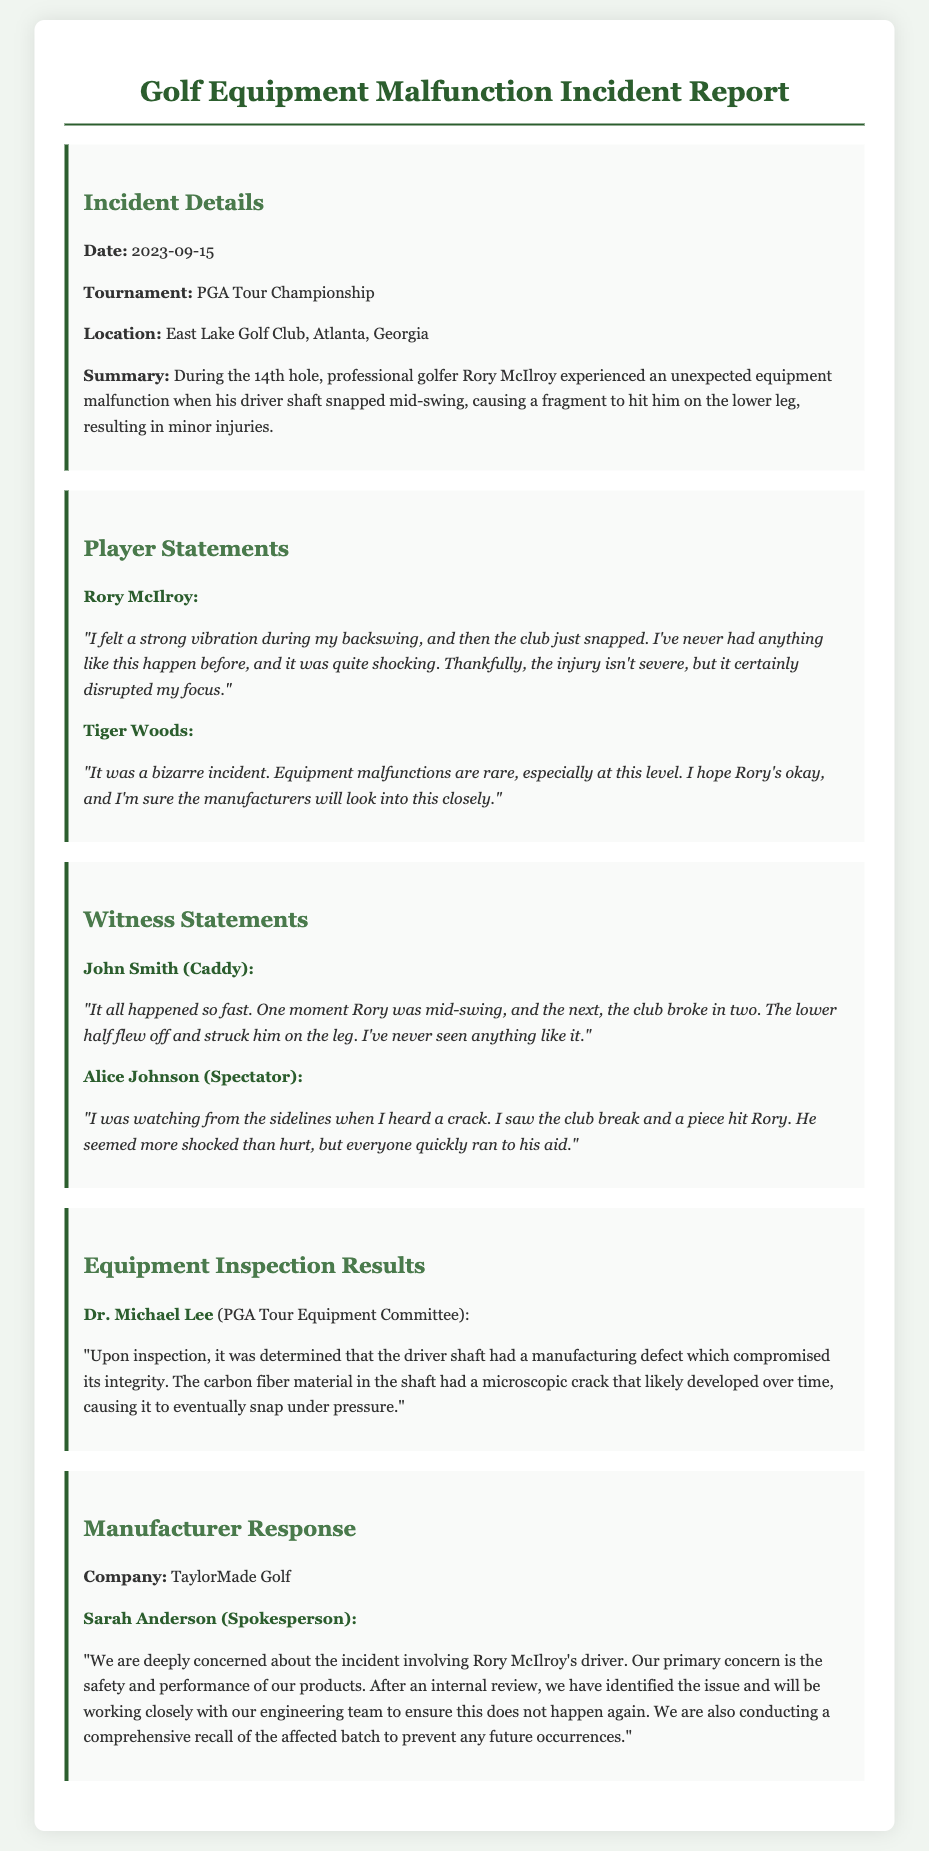What date did the incident occur? The date of the incident is specified in the document as 2023-09-15.
Answer: 2023-09-15 Who was the professional golfer involved in the incident? The document states that Rory McIlroy was the golfer who experienced the equipment malfunction.
Answer: Rory McIlroy What was the nature of Rory McIlroy's injury? The summary mentions that he sustained minor injuries due to the equipment malfunction.
Answer: Minor injuries What did Dr. Michael Lee conclude was the reason for the shaft snapping? Dr. Michael Lee's inspection revealed that there was a manufacturing defect in the driver shaft.
Answer: Manufacturing defect What was the reaction of Tiger Woods regarding the incident? Tiger Woods described the incident as bizarre and noted the rarity of equipment malfunctions at this level.
Answer: Bizarre incident What action is the manufacturer taking in response to the incident? TaylorMade Golf stated they are conducting a comprehensive recall of the affected batch.
Answer: Comprehensive recall How did Rory McIlroy feel during the incident? Rory McIlroy expressed it was shocking and disrupted his focus during play.
Answer: Shocking Who witnessed the incident besides Rory McIlroy? The document includes witness statements from John Smith and Alice Johnson.
Answer: John Smith and Alice Johnson 